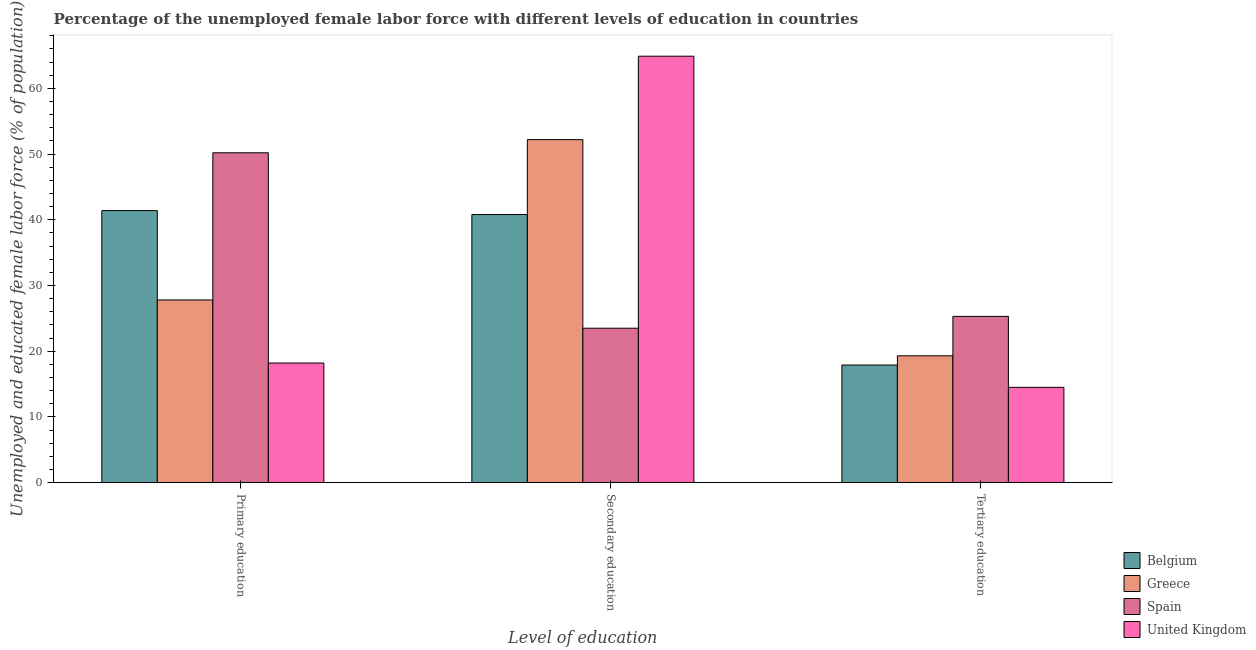How many different coloured bars are there?
Ensure brevity in your answer.  4. Are the number of bars per tick equal to the number of legend labels?
Your response must be concise. Yes. Are the number of bars on each tick of the X-axis equal?
Make the answer very short. Yes. What is the label of the 2nd group of bars from the left?
Make the answer very short. Secondary education. What is the percentage of female labor force who received primary education in United Kingdom?
Provide a succinct answer. 18.2. Across all countries, what is the maximum percentage of female labor force who received secondary education?
Offer a very short reply. 64.9. Across all countries, what is the minimum percentage of female labor force who received primary education?
Provide a short and direct response. 18.2. In which country was the percentage of female labor force who received secondary education minimum?
Offer a terse response. Spain. What is the total percentage of female labor force who received secondary education in the graph?
Offer a terse response. 181.4. What is the difference between the percentage of female labor force who received tertiary education in Greece and that in United Kingdom?
Your response must be concise. 4.8. What is the difference between the percentage of female labor force who received secondary education in United Kingdom and the percentage of female labor force who received tertiary education in Greece?
Keep it short and to the point. 45.6. What is the average percentage of female labor force who received primary education per country?
Your response must be concise. 34.4. What is the difference between the percentage of female labor force who received tertiary education and percentage of female labor force who received secondary education in Belgium?
Provide a short and direct response. -22.9. In how many countries, is the percentage of female labor force who received tertiary education greater than 56 %?
Your answer should be very brief. 0. What is the ratio of the percentage of female labor force who received tertiary education in Belgium to that in Spain?
Your response must be concise. 0.71. Is the difference between the percentage of female labor force who received tertiary education in United Kingdom and Belgium greater than the difference between the percentage of female labor force who received secondary education in United Kingdom and Belgium?
Give a very brief answer. No. What is the difference between the highest and the second highest percentage of female labor force who received secondary education?
Provide a succinct answer. 12.7. What is the difference between the highest and the lowest percentage of female labor force who received primary education?
Provide a short and direct response. 32. In how many countries, is the percentage of female labor force who received secondary education greater than the average percentage of female labor force who received secondary education taken over all countries?
Your response must be concise. 2. Is the sum of the percentage of female labor force who received tertiary education in Spain and Greece greater than the maximum percentage of female labor force who received primary education across all countries?
Your response must be concise. No. What does the 1st bar from the left in Tertiary education represents?
Your answer should be compact. Belgium. What is the difference between two consecutive major ticks on the Y-axis?
Offer a very short reply. 10. Does the graph contain grids?
Provide a short and direct response. No. Where does the legend appear in the graph?
Offer a very short reply. Bottom right. What is the title of the graph?
Provide a succinct answer. Percentage of the unemployed female labor force with different levels of education in countries. What is the label or title of the X-axis?
Ensure brevity in your answer.  Level of education. What is the label or title of the Y-axis?
Keep it short and to the point. Unemployed and educated female labor force (% of population). What is the Unemployed and educated female labor force (% of population) in Belgium in Primary education?
Offer a terse response. 41.4. What is the Unemployed and educated female labor force (% of population) in Greece in Primary education?
Keep it short and to the point. 27.8. What is the Unemployed and educated female labor force (% of population) of Spain in Primary education?
Offer a terse response. 50.2. What is the Unemployed and educated female labor force (% of population) of United Kingdom in Primary education?
Offer a very short reply. 18.2. What is the Unemployed and educated female labor force (% of population) in Belgium in Secondary education?
Provide a short and direct response. 40.8. What is the Unemployed and educated female labor force (% of population) in Greece in Secondary education?
Provide a short and direct response. 52.2. What is the Unemployed and educated female labor force (% of population) of Spain in Secondary education?
Offer a very short reply. 23.5. What is the Unemployed and educated female labor force (% of population) of United Kingdom in Secondary education?
Provide a short and direct response. 64.9. What is the Unemployed and educated female labor force (% of population) in Belgium in Tertiary education?
Offer a terse response. 17.9. What is the Unemployed and educated female labor force (% of population) of Greece in Tertiary education?
Make the answer very short. 19.3. What is the Unemployed and educated female labor force (% of population) in Spain in Tertiary education?
Your answer should be compact. 25.3. What is the Unemployed and educated female labor force (% of population) of United Kingdom in Tertiary education?
Your answer should be compact. 14.5. Across all Level of education, what is the maximum Unemployed and educated female labor force (% of population) of Belgium?
Your answer should be compact. 41.4. Across all Level of education, what is the maximum Unemployed and educated female labor force (% of population) of Greece?
Your response must be concise. 52.2. Across all Level of education, what is the maximum Unemployed and educated female labor force (% of population) of Spain?
Your answer should be very brief. 50.2. Across all Level of education, what is the maximum Unemployed and educated female labor force (% of population) in United Kingdom?
Your response must be concise. 64.9. Across all Level of education, what is the minimum Unemployed and educated female labor force (% of population) of Belgium?
Your answer should be compact. 17.9. Across all Level of education, what is the minimum Unemployed and educated female labor force (% of population) in Greece?
Ensure brevity in your answer.  19.3. Across all Level of education, what is the minimum Unemployed and educated female labor force (% of population) of Spain?
Provide a short and direct response. 23.5. Across all Level of education, what is the minimum Unemployed and educated female labor force (% of population) in United Kingdom?
Your response must be concise. 14.5. What is the total Unemployed and educated female labor force (% of population) of Belgium in the graph?
Keep it short and to the point. 100.1. What is the total Unemployed and educated female labor force (% of population) in Greece in the graph?
Your answer should be very brief. 99.3. What is the total Unemployed and educated female labor force (% of population) of Spain in the graph?
Offer a terse response. 99. What is the total Unemployed and educated female labor force (% of population) of United Kingdom in the graph?
Your answer should be compact. 97.6. What is the difference between the Unemployed and educated female labor force (% of population) in Greece in Primary education and that in Secondary education?
Provide a succinct answer. -24.4. What is the difference between the Unemployed and educated female labor force (% of population) in Spain in Primary education and that in Secondary education?
Make the answer very short. 26.7. What is the difference between the Unemployed and educated female labor force (% of population) in United Kingdom in Primary education and that in Secondary education?
Your answer should be very brief. -46.7. What is the difference between the Unemployed and educated female labor force (% of population) of Spain in Primary education and that in Tertiary education?
Your answer should be very brief. 24.9. What is the difference between the Unemployed and educated female labor force (% of population) of Belgium in Secondary education and that in Tertiary education?
Keep it short and to the point. 22.9. What is the difference between the Unemployed and educated female labor force (% of population) of Greece in Secondary education and that in Tertiary education?
Ensure brevity in your answer.  32.9. What is the difference between the Unemployed and educated female labor force (% of population) in Spain in Secondary education and that in Tertiary education?
Offer a very short reply. -1.8. What is the difference between the Unemployed and educated female labor force (% of population) of United Kingdom in Secondary education and that in Tertiary education?
Your answer should be very brief. 50.4. What is the difference between the Unemployed and educated female labor force (% of population) in Belgium in Primary education and the Unemployed and educated female labor force (% of population) in Greece in Secondary education?
Your response must be concise. -10.8. What is the difference between the Unemployed and educated female labor force (% of population) in Belgium in Primary education and the Unemployed and educated female labor force (% of population) in Spain in Secondary education?
Offer a terse response. 17.9. What is the difference between the Unemployed and educated female labor force (% of population) of Belgium in Primary education and the Unemployed and educated female labor force (% of population) of United Kingdom in Secondary education?
Your response must be concise. -23.5. What is the difference between the Unemployed and educated female labor force (% of population) in Greece in Primary education and the Unemployed and educated female labor force (% of population) in United Kingdom in Secondary education?
Ensure brevity in your answer.  -37.1. What is the difference between the Unemployed and educated female labor force (% of population) in Spain in Primary education and the Unemployed and educated female labor force (% of population) in United Kingdom in Secondary education?
Your response must be concise. -14.7. What is the difference between the Unemployed and educated female labor force (% of population) of Belgium in Primary education and the Unemployed and educated female labor force (% of population) of Greece in Tertiary education?
Provide a succinct answer. 22.1. What is the difference between the Unemployed and educated female labor force (% of population) in Belgium in Primary education and the Unemployed and educated female labor force (% of population) in United Kingdom in Tertiary education?
Offer a terse response. 26.9. What is the difference between the Unemployed and educated female labor force (% of population) of Greece in Primary education and the Unemployed and educated female labor force (% of population) of United Kingdom in Tertiary education?
Provide a short and direct response. 13.3. What is the difference between the Unemployed and educated female labor force (% of population) of Spain in Primary education and the Unemployed and educated female labor force (% of population) of United Kingdom in Tertiary education?
Give a very brief answer. 35.7. What is the difference between the Unemployed and educated female labor force (% of population) of Belgium in Secondary education and the Unemployed and educated female labor force (% of population) of Greece in Tertiary education?
Make the answer very short. 21.5. What is the difference between the Unemployed and educated female labor force (% of population) of Belgium in Secondary education and the Unemployed and educated female labor force (% of population) of Spain in Tertiary education?
Make the answer very short. 15.5. What is the difference between the Unemployed and educated female labor force (% of population) of Belgium in Secondary education and the Unemployed and educated female labor force (% of population) of United Kingdom in Tertiary education?
Keep it short and to the point. 26.3. What is the difference between the Unemployed and educated female labor force (% of population) of Greece in Secondary education and the Unemployed and educated female labor force (% of population) of Spain in Tertiary education?
Offer a very short reply. 26.9. What is the difference between the Unemployed and educated female labor force (% of population) in Greece in Secondary education and the Unemployed and educated female labor force (% of population) in United Kingdom in Tertiary education?
Give a very brief answer. 37.7. What is the average Unemployed and educated female labor force (% of population) of Belgium per Level of education?
Offer a very short reply. 33.37. What is the average Unemployed and educated female labor force (% of population) in Greece per Level of education?
Provide a succinct answer. 33.1. What is the average Unemployed and educated female labor force (% of population) of Spain per Level of education?
Provide a succinct answer. 33. What is the average Unemployed and educated female labor force (% of population) in United Kingdom per Level of education?
Give a very brief answer. 32.53. What is the difference between the Unemployed and educated female labor force (% of population) of Belgium and Unemployed and educated female labor force (% of population) of Greece in Primary education?
Give a very brief answer. 13.6. What is the difference between the Unemployed and educated female labor force (% of population) in Belgium and Unemployed and educated female labor force (% of population) in Spain in Primary education?
Provide a short and direct response. -8.8. What is the difference between the Unemployed and educated female labor force (% of population) of Belgium and Unemployed and educated female labor force (% of population) of United Kingdom in Primary education?
Ensure brevity in your answer.  23.2. What is the difference between the Unemployed and educated female labor force (% of population) in Greece and Unemployed and educated female labor force (% of population) in Spain in Primary education?
Your answer should be compact. -22.4. What is the difference between the Unemployed and educated female labor force (% of population) of Belgium and Unemployed and educated female labor force (% of population) of United Kingdom in Secondary education?
Keep it short and to the point. -24.1. What is the difference between the Unemployed and educated female labor force (% of population) of Greece and Unemployed and educated female labor force (% of population) of Spain in Secondary education?
Ensure brevity in your answer.  28.7. What is the difference between the Unemployed and educated female labor force (% of population) in Greece and Unemployed and educated female labor force (% of population) in United Kingdom in Secondary education?
Make the answer very short. -12.7. What is the difference between the Unemployed and educated female labor force (% of population) of Spain and Unemployed and educated female labor force (% of population) of United Kingdom in Secondary education?
Offer a very short reply. -41.4. What is the difference between the Unemployed and educated female labor force (% of population) in Belgium and Unemployed and educated female labor force (% of population) in United Kingdom in Tertiary education?
Provide a short and direct response. 3.4. What is the difference between the Unemployed and educated female labor force (% of population) of Greece and Unemployed and educated female labor force (% of population) of United Kingdom in Tertiary education?
Offer a very short reply. 4.8. What is the difference between the Unemployed and educated female labor force (% of population) of Spain and Unemployed and educated female labor force (% of population) of United Kingdom in Tertiary education?
Give a very brief answer. 10.8. What is the ratio of the Unemployed and educated female labor force (% of population) in Belgium in Primary education to that in Secondary education?
Offer a very short reply. 1.01. What is the ratio of the Unemployed and educated female labor force (% of population) of Greece in Primary education to that in Secondary education?
Provide a short and direct response. 0.53. What is the ratio of the Unemployed and educated female labor force (% of population) in Spain in Primary education to that in Secondary education?
Give a very brief answer. 2.14. What is the ratio of the Unemployed and educated female labor force (% of population) in United Kingdom in Primary education to that in Secondary education?
Provide a short and direct response. 0.28. What is the ratio of the Unemployed and educated female labor force (% of population) of Belgium in Primary education to that in Tertiary education?
Your answer should be very brief. 2.31. What is the ratio of the Unemployed and educated female labor force (% of population) of Greece in Primary education to that in Tertiary education?
Your answer should be compact. 1.44. What is the ratio of the Unemployed and educated female labor force (% of population) in Spain in Primary education to that in Tertiary education?
Make the answer very short. 1.98. What is the ratio of the Unemployed and educated female labor force (% of population) of United Kingdom in Primary education to that in Tertiary education?
Your answer should be very brief. 1.26. What is the ratio of the Unemployed and educated female labor force (% of population) of Belgium in Secondary education to that in Tertiary education?
Ensure brevity in your answer.  2.28. What is the ratio of the Unemployed and educated female labor force (% of population) in Greece in Secondary education to that in Tertiary education?
Your answer should be very brief. 2.7. What is the ratio of the Unemployed and educated female labor force (% of population) of Spain in Secondary education to that in Tertiary education?
Provide a short and direct response. 0.93. What is the ratio of the Unemployed and educated female labor force (% of population) of United Kingdom in Secondary education to that in Tertiary education?
Keep it short and to the point. 4.48. What is the difference between the highest and the second highest Unemployed and educated female labor force (% of population) in Greece?
Make the answer very short. 24.4. What is the difference between the highest and the second highest Unemployed and educated female labor force (% of population) of Spain?
Offer a terse response. 24.9. What is the difference between the highest and the second highest Unemployed and educated female labor force (% of population) in United Kingdom?
Make the answer very short. 46.7. What is the difference between the highest and the lowest Unemployed and educated female labor force (% of population) of Greece?
Ensure brevity in your answer.  32.9. What is the difference between the highest and the lowest Unemployed and educated female labor force (% of population) of Spain?
Your answer should be very brief. 26.7. What is the difference between the highest and the lowest Unemployed and educated female labor force (% of population) of United Kingdom?
Provide a short and direct response. 50.4. 